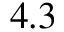Convert formula to latex. <formula><loc_0><loc_0><loc_500><loc_500>4 . 3</formula> 